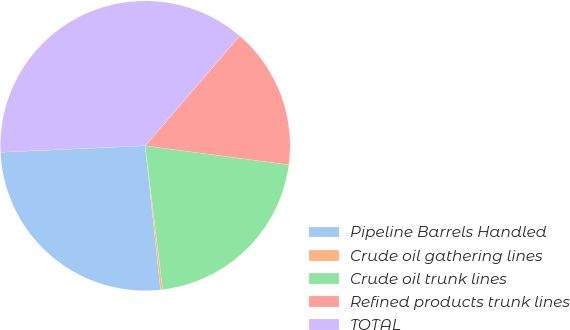Convert chart to OTSL. <chart><loc_0><loc_0><loc_500><loc_500><pie_chart><fcel>Pipeline Barrels Handled<fcel>Crude oil gathering lines<fcel>Crude oil trunk lines<fcel>Refined products trunk lines<fcel>TOTAL<nl><fcel>25.98%<fcel>0.23%<fcel>20.98%<fcel>15.8%<fcel>37.01%<nl></chart> 